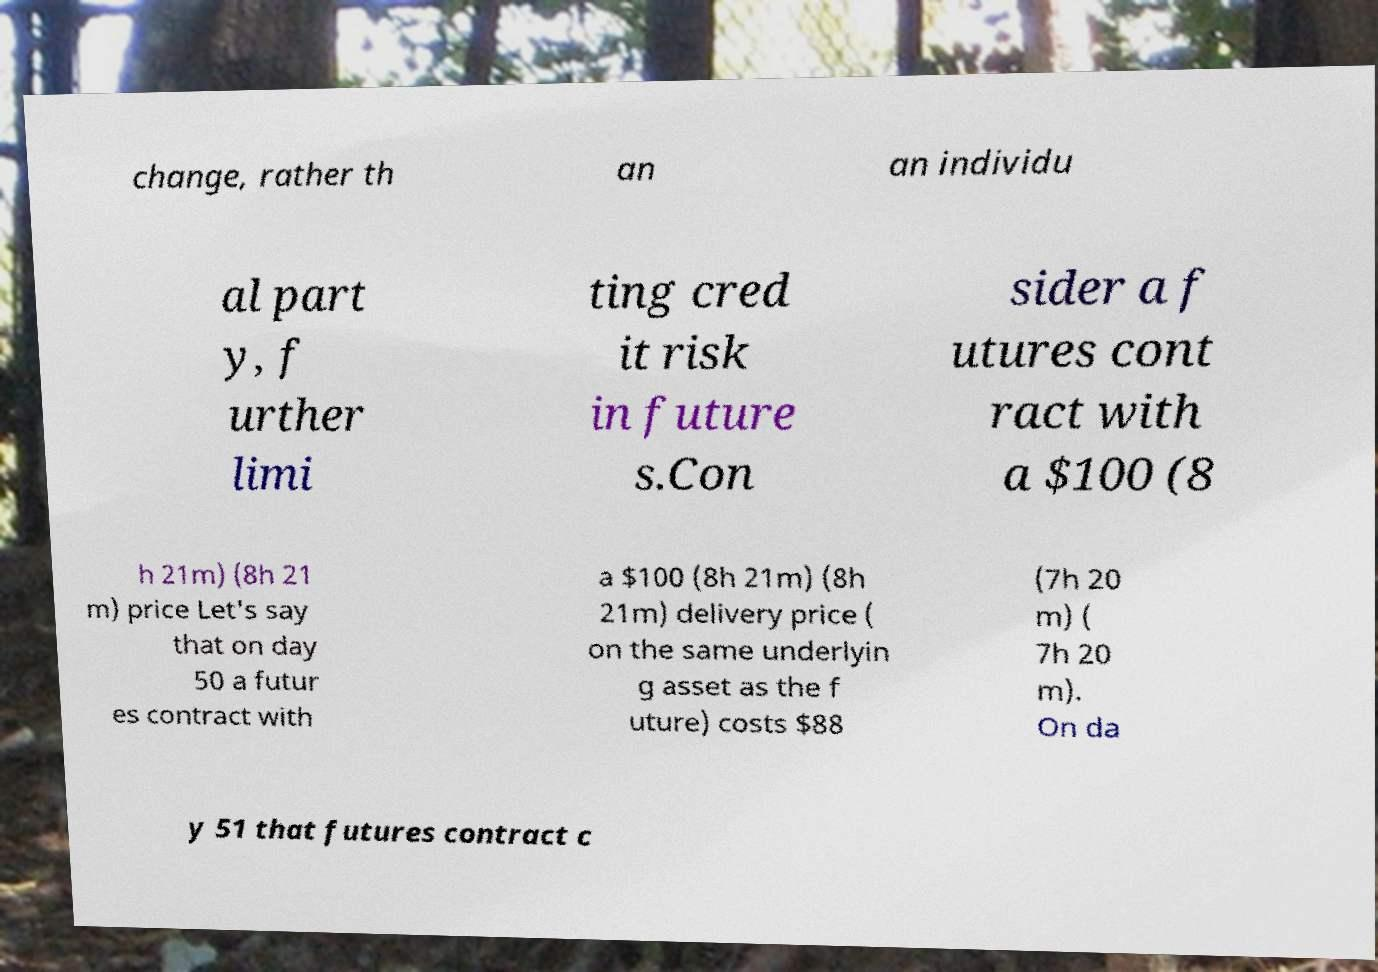Can you accurately transcribe the text from the provided image for me? change, rather th an an individu al part y, f urther limi ting cred it risk in future s.Con sider a f utures cont ract with a $100 (8 h 21m) (8h 21 m) price Let's say that on day 50 a futur es contract with a $100 (8h 21m) (8h 21m) delivery price ( on the same underlyin g asset as the f uture) costs $88 (7h 20 m) ( 7h 20 m). On da y 51 that futures contract c 